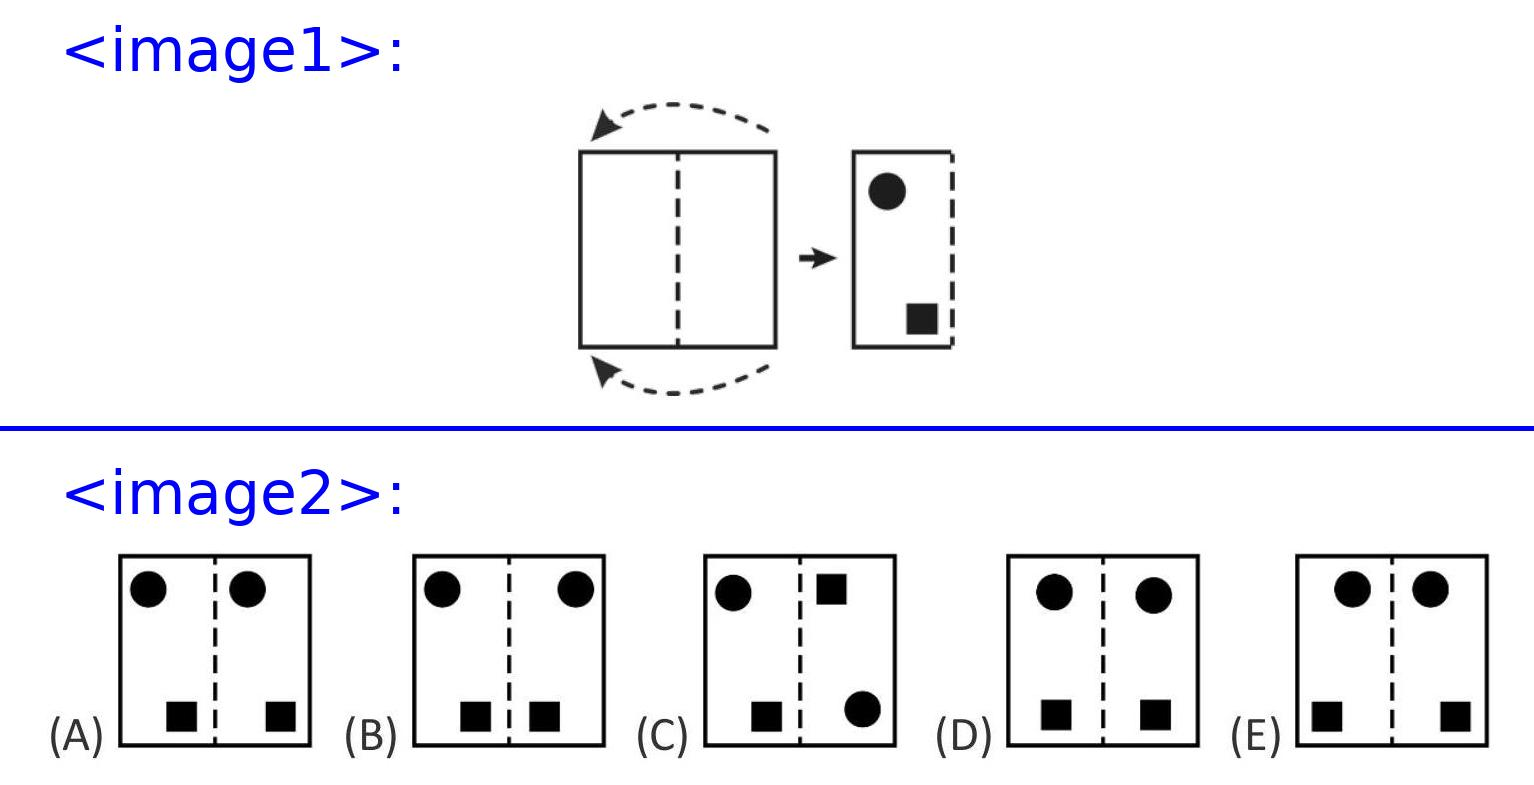Susi folds a piece of paper in the middle. She stamps 2 holes.
What does the piece of paper look like when she unfolds it again?
<image2> Choices: ['A', 'B', 'C', 'D', 'E'] Answer is B. 